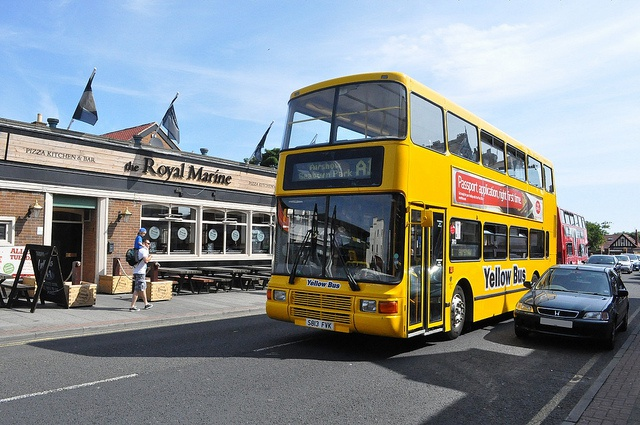Describe the objects in this image and their specific colors. I can see bus in lightblue, black, gray, gold, and olive tones, car in lightblue, black, and gray tones, bus in lightblue, lavender, darkgray, maroon, and gray tones, people in lightblue, gray, lightgray, black, and darkgray tones, and car in lightblue and gray tones in this image. 